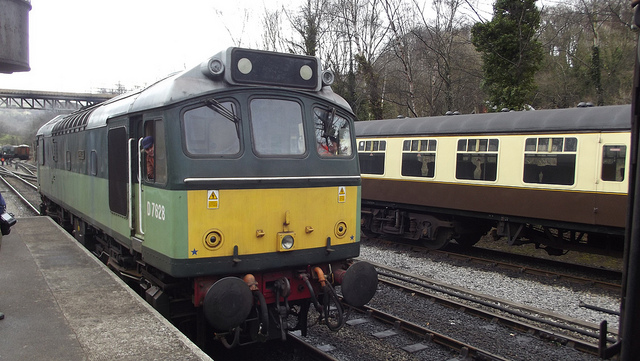Read all the text in this image. D7628 